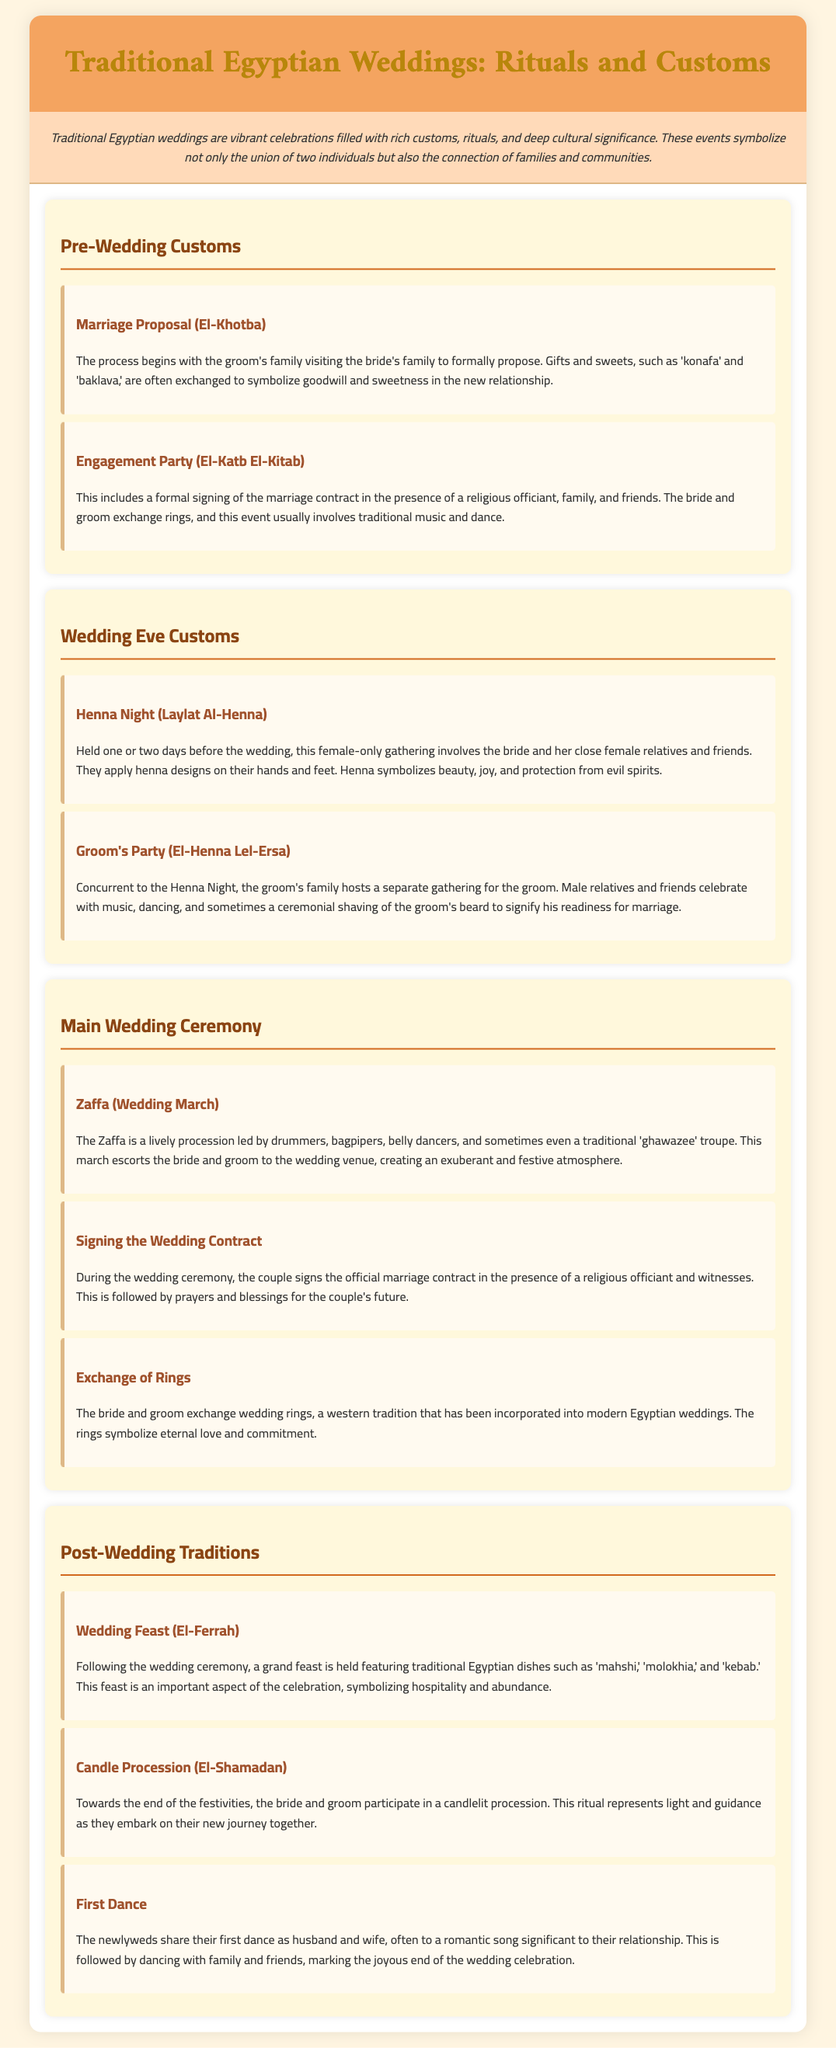What is the name of the marriage proposal ceremony in Egypt? The first step in the wedding customs is the marriage proposal, referred to as El-Khotba in the document.
Answer: El-Khotba What is exchanged during the engagement party? The engagement party includes the exchange of rings between the bride and groom, as stated in the document.
Answer: Rings What does henna symbolize? The document mentions that henna symbolizes beauty, joy, and protection from evil spirits.
Answer: Beauty, joy, and protection What is the Zaffa? The Zaffa is described as a lively procession that leads the bride and groom to the wedding venue, creating a festive atmosphere.
Answer: Wedding March What type of food is served at the wedding feast? The document lists traditional Egyptian dishes like mahshi, molokhia, and kebab as part of the wedding feast.
Answer: Mahshi, molokhia, kebab How many customs are mentioned in the "Main Wedding Ceremony" section? The number of subsections within the "Main Wedding Ceremony" section is counted for this question. There are three customs mentioned.
Answer: Three What ritual occurs towards the end of the festivities? The document indicates that a candlelit procession takes place towards the end of the wedding celebrations.
Answer: Candle Procession What is the significance of the first dance? The first dance represents a significant moment for the newlyweds, marking the joyous end of the wedding celebration.
Answer: Joyous end of celebration 